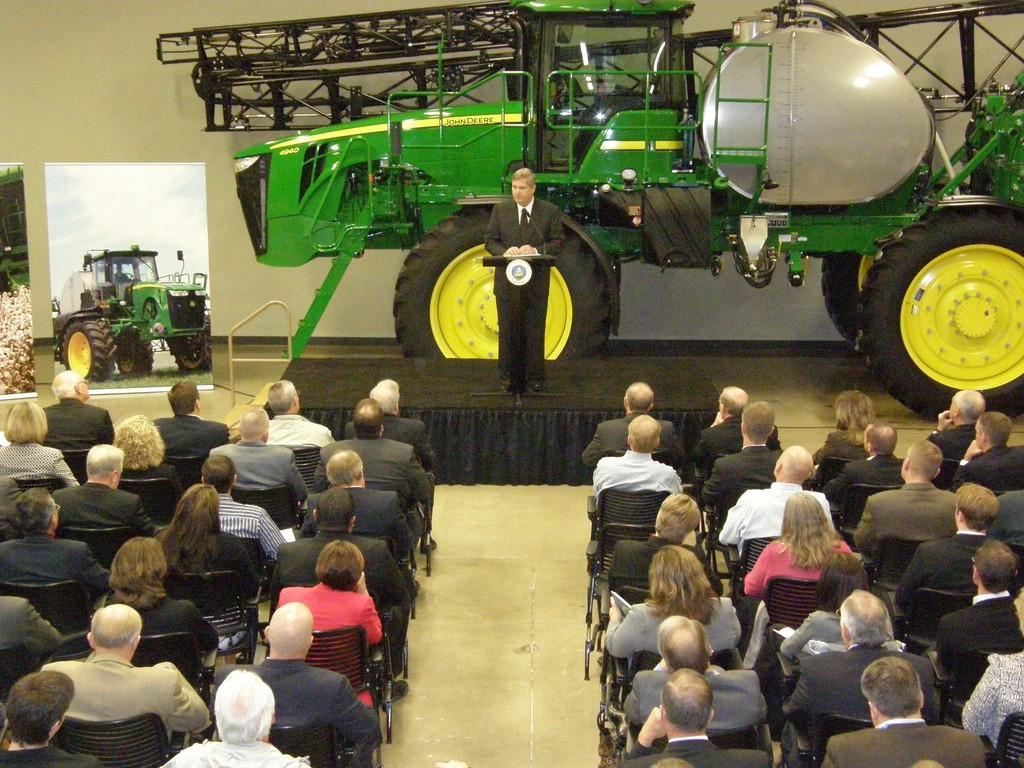How would you summarize this image in a sentence or two? In this image we can see many people sitting on the chairs. A person is standing on the stage near the podium and addressing the gathering. There is a vehicle in the image. There are few banners at the left side of the image. 